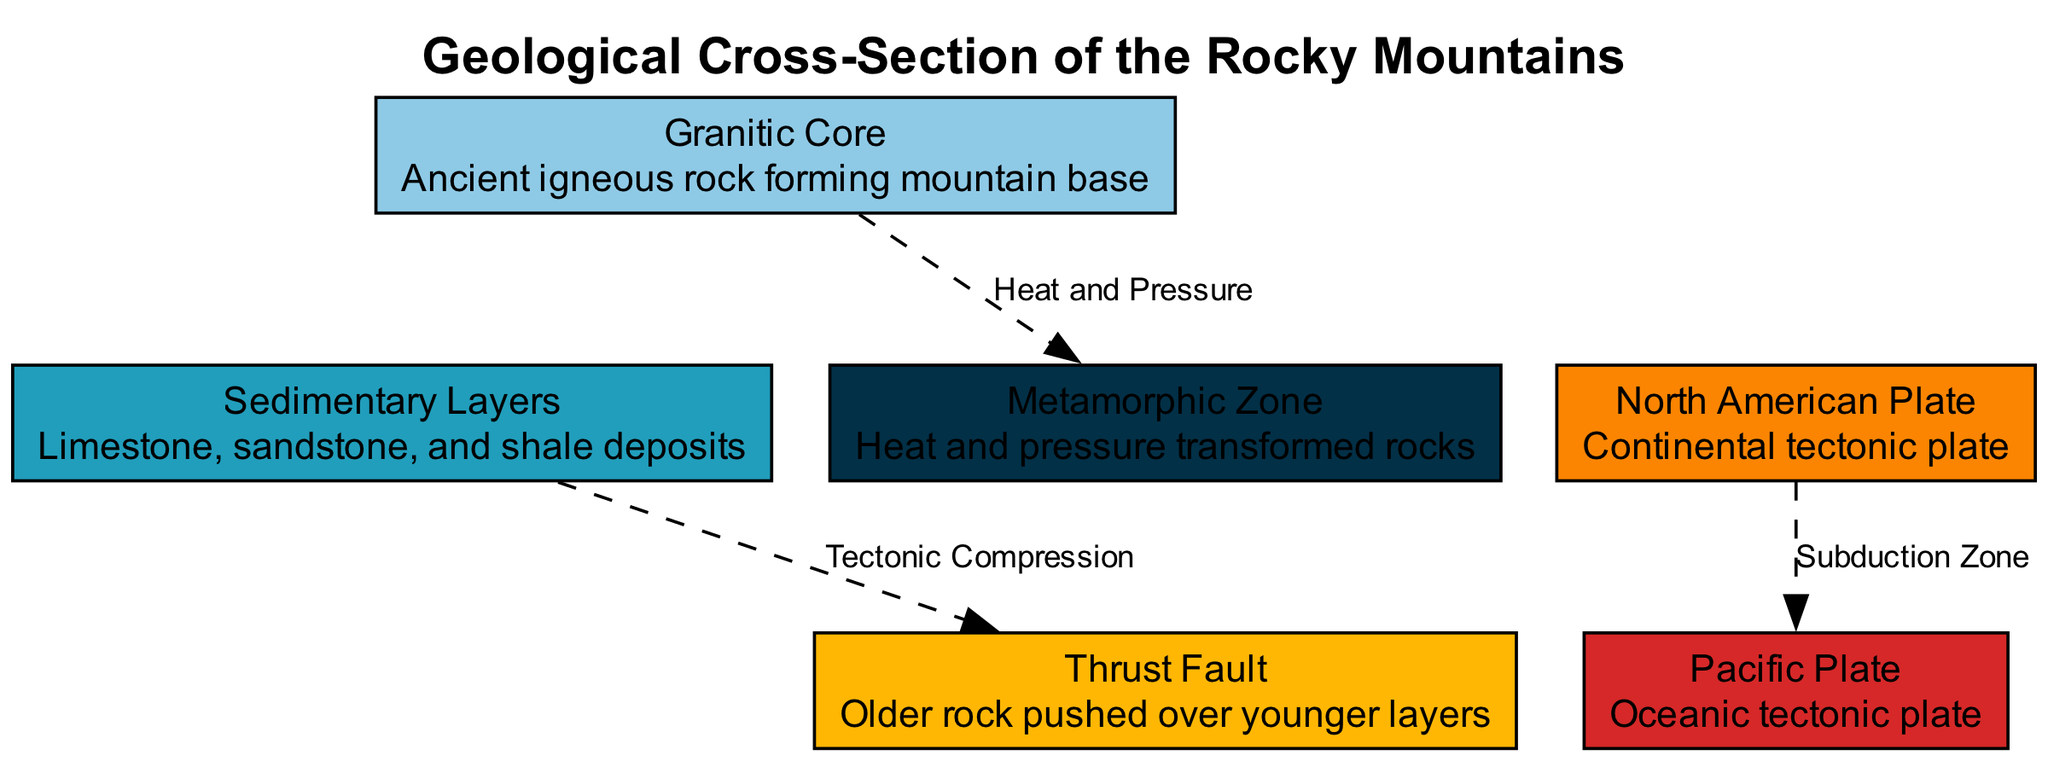What is the main type of rock at the mountain's base? The diagram indicates that the "Granitic Core" forms the base of the mountain, which is described as ancient igneous rock.
Answer: Granitic Core How many nodes are there in the diagram? By counting the listed nodes, we find there are six distinct nodes representing different geological features.
Answer: 6 What type of fault is represented in the diagram? The diagram labels the fault as a "Thrust Fault," indicating a specific geological process occurring between the rock layers.
Answer: Thrust Fault Which plate is the North American Plate interacting with? The edges in the diagram show a direct connection labeled "Subduction Zone" indicating the North American Plate is interacting with the Pacific Plate.
Answer: Pacific Plate What process transforms rocks in the Metamorphic Zone? The arrow from the "Granitic Core" to the "Metamorphic Zone" is labeled "Heat and Pressure," indicating this is the process responsible for the transformation.
Answer: Heat and Pressure How do the Sedimentary Layers relate to the Thrust Fault? The edge between "Sedimentary Layers" and "Thrust Fault" is labeled "Tectonic Compression," which shows that the relationship is caused by this geological force.
Answer: Tectonic Compression What is the label describing the relationship between the North American Plate and the Pacific Plate? The diagram clearly shows the connection labeled "Subduction Zone," indicating the nature of their interaction.
Answer: Subduction Zone Which geological zone is described as the area of heat and pressure transformation? The diagram identifies the "Metamorphic Zone" as the area where heat and pressure are responsible for the transformation of rocks.
Answer: Metamorphic Zone 